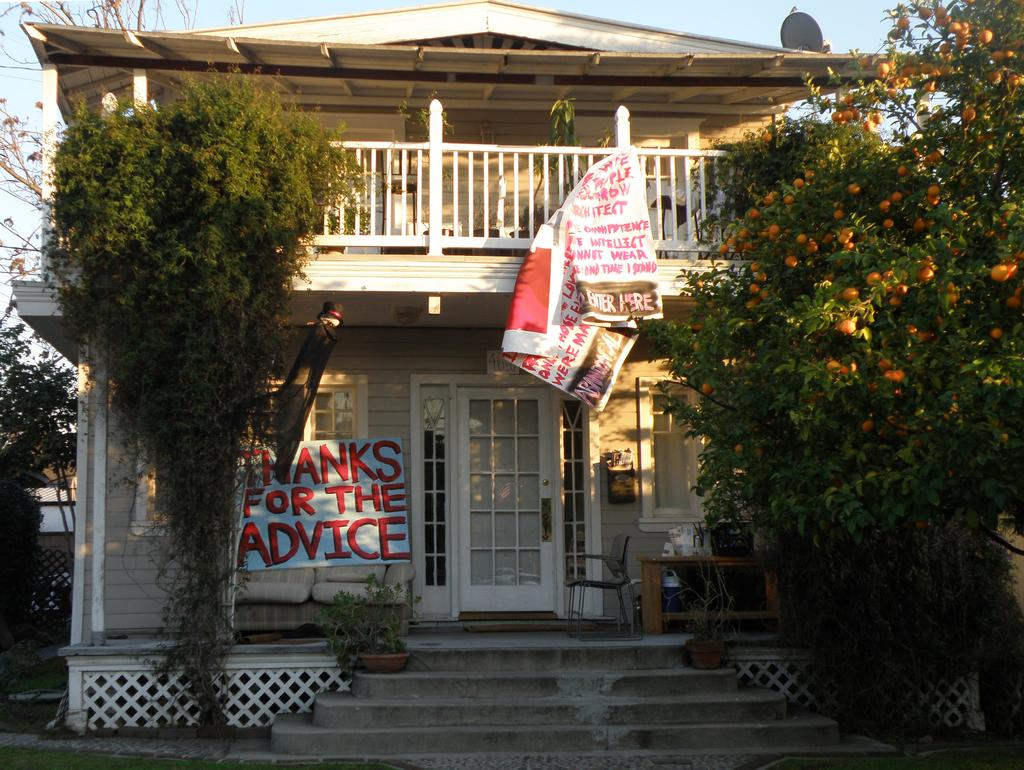<image>
Write a terse but informative summary of the picture. a house with a banner that says thank for the advice 